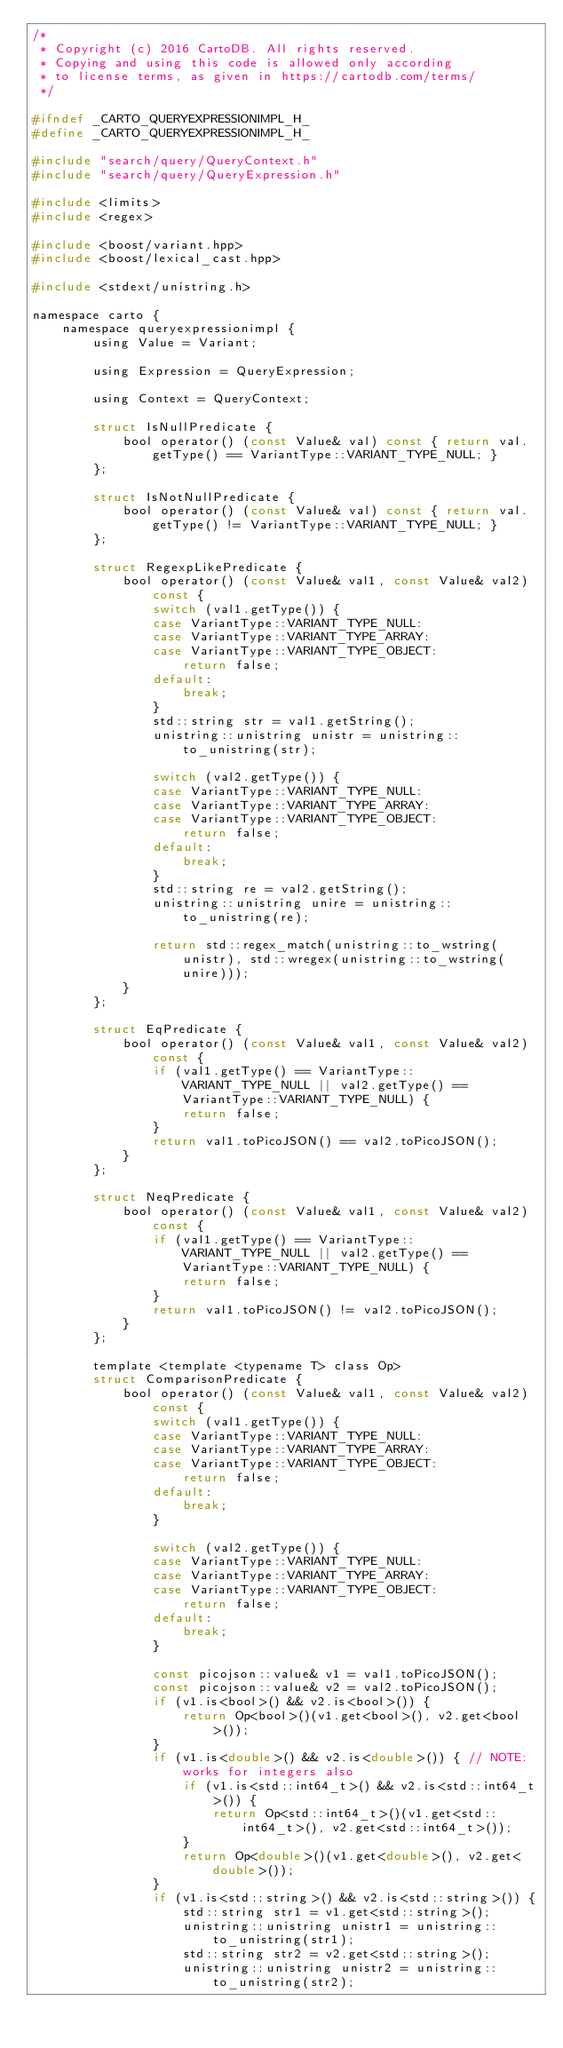Convert code to text. <code><loc_0><loc_0><loc_500><loc_500><_C_>/*
 * Copyright (c) 2016 CartoDB. All rights reserved.
 * Copying and using this code is allowed only according
 * to license terms, as given in https://cartodb.com/terms/
 */

#ifndef _CARTO_QUERYEXPRESSIONIMPL_H_
#define _CARTO_QUERYEXPRESSIONIMPL_H_

#include "search/query/QueryContext.h"
#include "search/query/QueryExpression.h"

#include <limits>
#include <regex>

#include <boost/variant.hpp>
#include <boost/lexical_cast.hpp>

#include <stdext/unistring.h>

namespace carto {
    namespace queryexpressionimpl {
        using Value = Variant;

        using Expression = QueryExpression;

        using Context = QueryContext;

        struct IsNullPredicate {
            bool operator() (const Value& val) const { return val.getType() == VariantType::VARIANT_TYPE_NULL; }
        };

        struct IsNotNullPredicate {
            bool operator() (const Value& val) const { return val.getType() != VariantType::VARIANT_TYPE_NULL; }
        };

        struct RegexpLikePredicate {
            bool operator() (const Value& val1, const Value& val2) const {
                switch (val1.getType()) {
                case VariantType::VARIANT_TYPE_NULL:
                case VariantType::VARIANT_TYPE_ARRAY:
                case VariantType::VARIANT_TYPE_OBJECT:
                    return false;
                default:
                    break;
                }
                std::string str = val1.getString();
                unistring::unistring unistr = unistring::to_unistring(str);

                switch (val2.getType()) {
                case VariantType::VARIANT_TYPE_NULL:
                case VariantType::VARIANT_TYPE_ARRAY:
                case VariantType::VARIANT_TYPE_OBJECT:
                    return false;
                default:
                    break;
                }
                std::string re = val2.getString();
                unistring::unistring unire = unistring::to_unistring(re);

                return std::regex_match(unistring::to_wstring(unistr), std::wregex(unistring::to_wstring(unire)));
            }
        };

        struct EqPredicate {
            bool operator() (const Value& val1, const Value& val2) const {
                if (val1.getType() == VariantType::VARIANT_TYPE_NULL || val2.getType() == VariantType::VARIANT_TYPE_NULL) {
                    return false;
                }
                return val1.toPicoJSON() == val2.toPicoJSON();
            }
        };

        struct NeqPredicate {
            bool operator() (const Value& val1, const Value& val2) const {
                if (val1.getType() == VariantType::VARIANT_TYPE_NULL || val2.getType() == VariantType::VARIANT_TYPE_NULL) {
                    return false;
                }
                return val1.toPicoJSON() != val2.toPicoJSON();
            }
        };

        template <template <typename T> class Op>
        struct ComparisonPredicate {
            bool operator() (const Value& val1, const Value& val2) const {
                switch (val1.getType()) {
                case VariantType::VARIANT_TYPE_NULL:
                case VariantType::VARIANT_TYPE_ARRAY:
                case VariantType::VARIANT_TYPE_OBJECT:
                    return false;
                default:
                    break;
                }

                switch (val2.getType()) {
                case VariantType::VARIANT_TYPE_NULL:
                case VariantType::VARIANT_TYPE_ARRAY:
                case VariantType::VARIANT_TYPE_OBJECT:
                    return false;
                default:
                    break;
                }

                const picojson::value& v1 = val1.toPicoJSON();
                const picojson::value& v2 = val2.toPicoJSON();
                if (v1.is<bool>() && v2.is<bool>()) {
                    return Op<bool>()(v1.get<bool>(), v2.get<bool>());
                }
                if (v1.is<double>() && v2.is<double>()) { // NOTE: works for integers also
                    if (v1.is<std::int64_t>() && v2.is<std::int64_t>()) {
                        return Op<std::int64_t>()(v1.get<std::int64_t>(), v2.get<std::int64_t>());
                    }
                    return Op<double>()(v1.get<double>(), v2.get<double>());
                }
                if (v1.is<std::string>() && v2.is<std::string>()) {
                    std::string str1 = v1.get<std::string>();
                    unistring::unistring unistr1 = unistring::to_unistring(str1);
                    std::string str2 = v2.get<std::string>();
                    unistring::unistring unistr2 = unistring::to_unistring(str2);</code> 